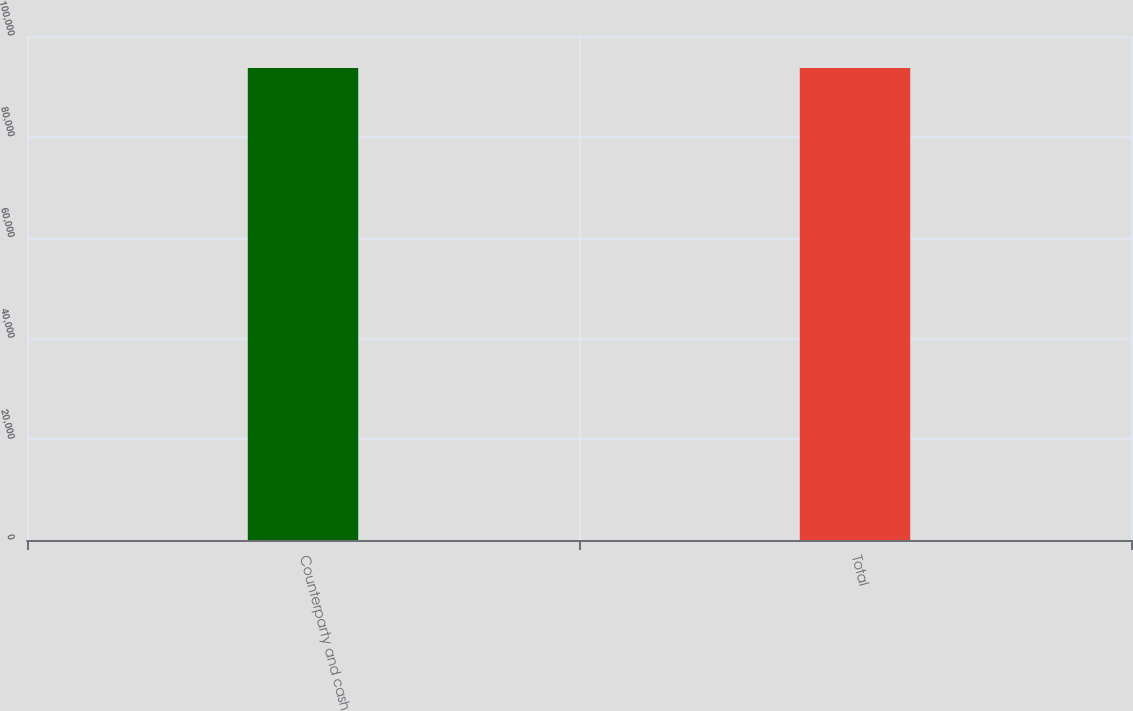Convert chart to OTSL. <chart><loc_0><loc_0><loc_500><loc_500><bar_chart><fcel>Counterparty and cash<fcel>Total<nl><fcel>93643<fcel>93643.1<nl></chart> 